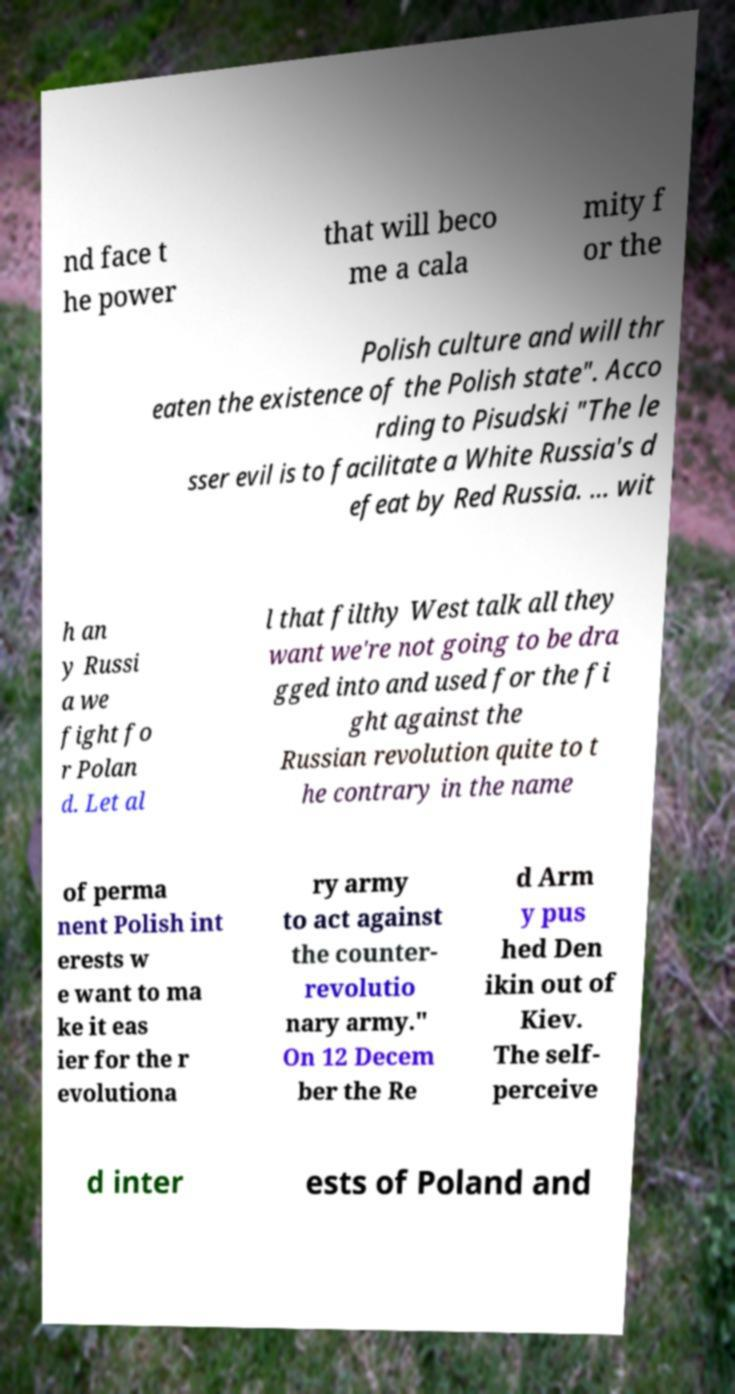Can you read and provide the text displayed in the image?This photo seems to have some interesting text. Can you extract and type it out for me? nd face t he power that will beco me a cala mity f or the Polish culture and will thr eaten the existence of the Polish state". Acco rding to Pisudski "The le sser evil is to facilitate a White Russia's d efeat by Red Russia. ... wit h an y Russi a we fight fo r Polan d. Let al l that filthy West talk all they want we're not going to be dra gged into and used for the fi ght against the Russian revolution quite to t he contrary in the name of perma nent Polish int erests w e want to ma ke it eas ier for the r evolutiona ry army to act against the counter- revolutio nary army." On 12 Decem ber the Re d Arm y pus hed Den ikin out of Kiev. The self- perceive d inter ests of Poland and 